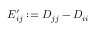Convert formula to latex. <formula><loc_0><loc_0><loc_500><loc_500>E _ { i j } ^ { \prime } \colon = D _ { j j } - D _ { i i }</formula> 